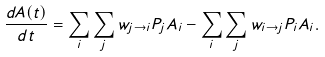<formula> <loc_0><loc_0><loc_500><loc_500>\frac { d A ( t ) } { d t } = \sum _ { i } \sum _ { j } w _ { j \rightarrow i } P _ { j } A _ { i } - \sum _ { i } \sum _ { j } w _ { i \rightarrow j } P _ { i } A _ { i } .</formula> 